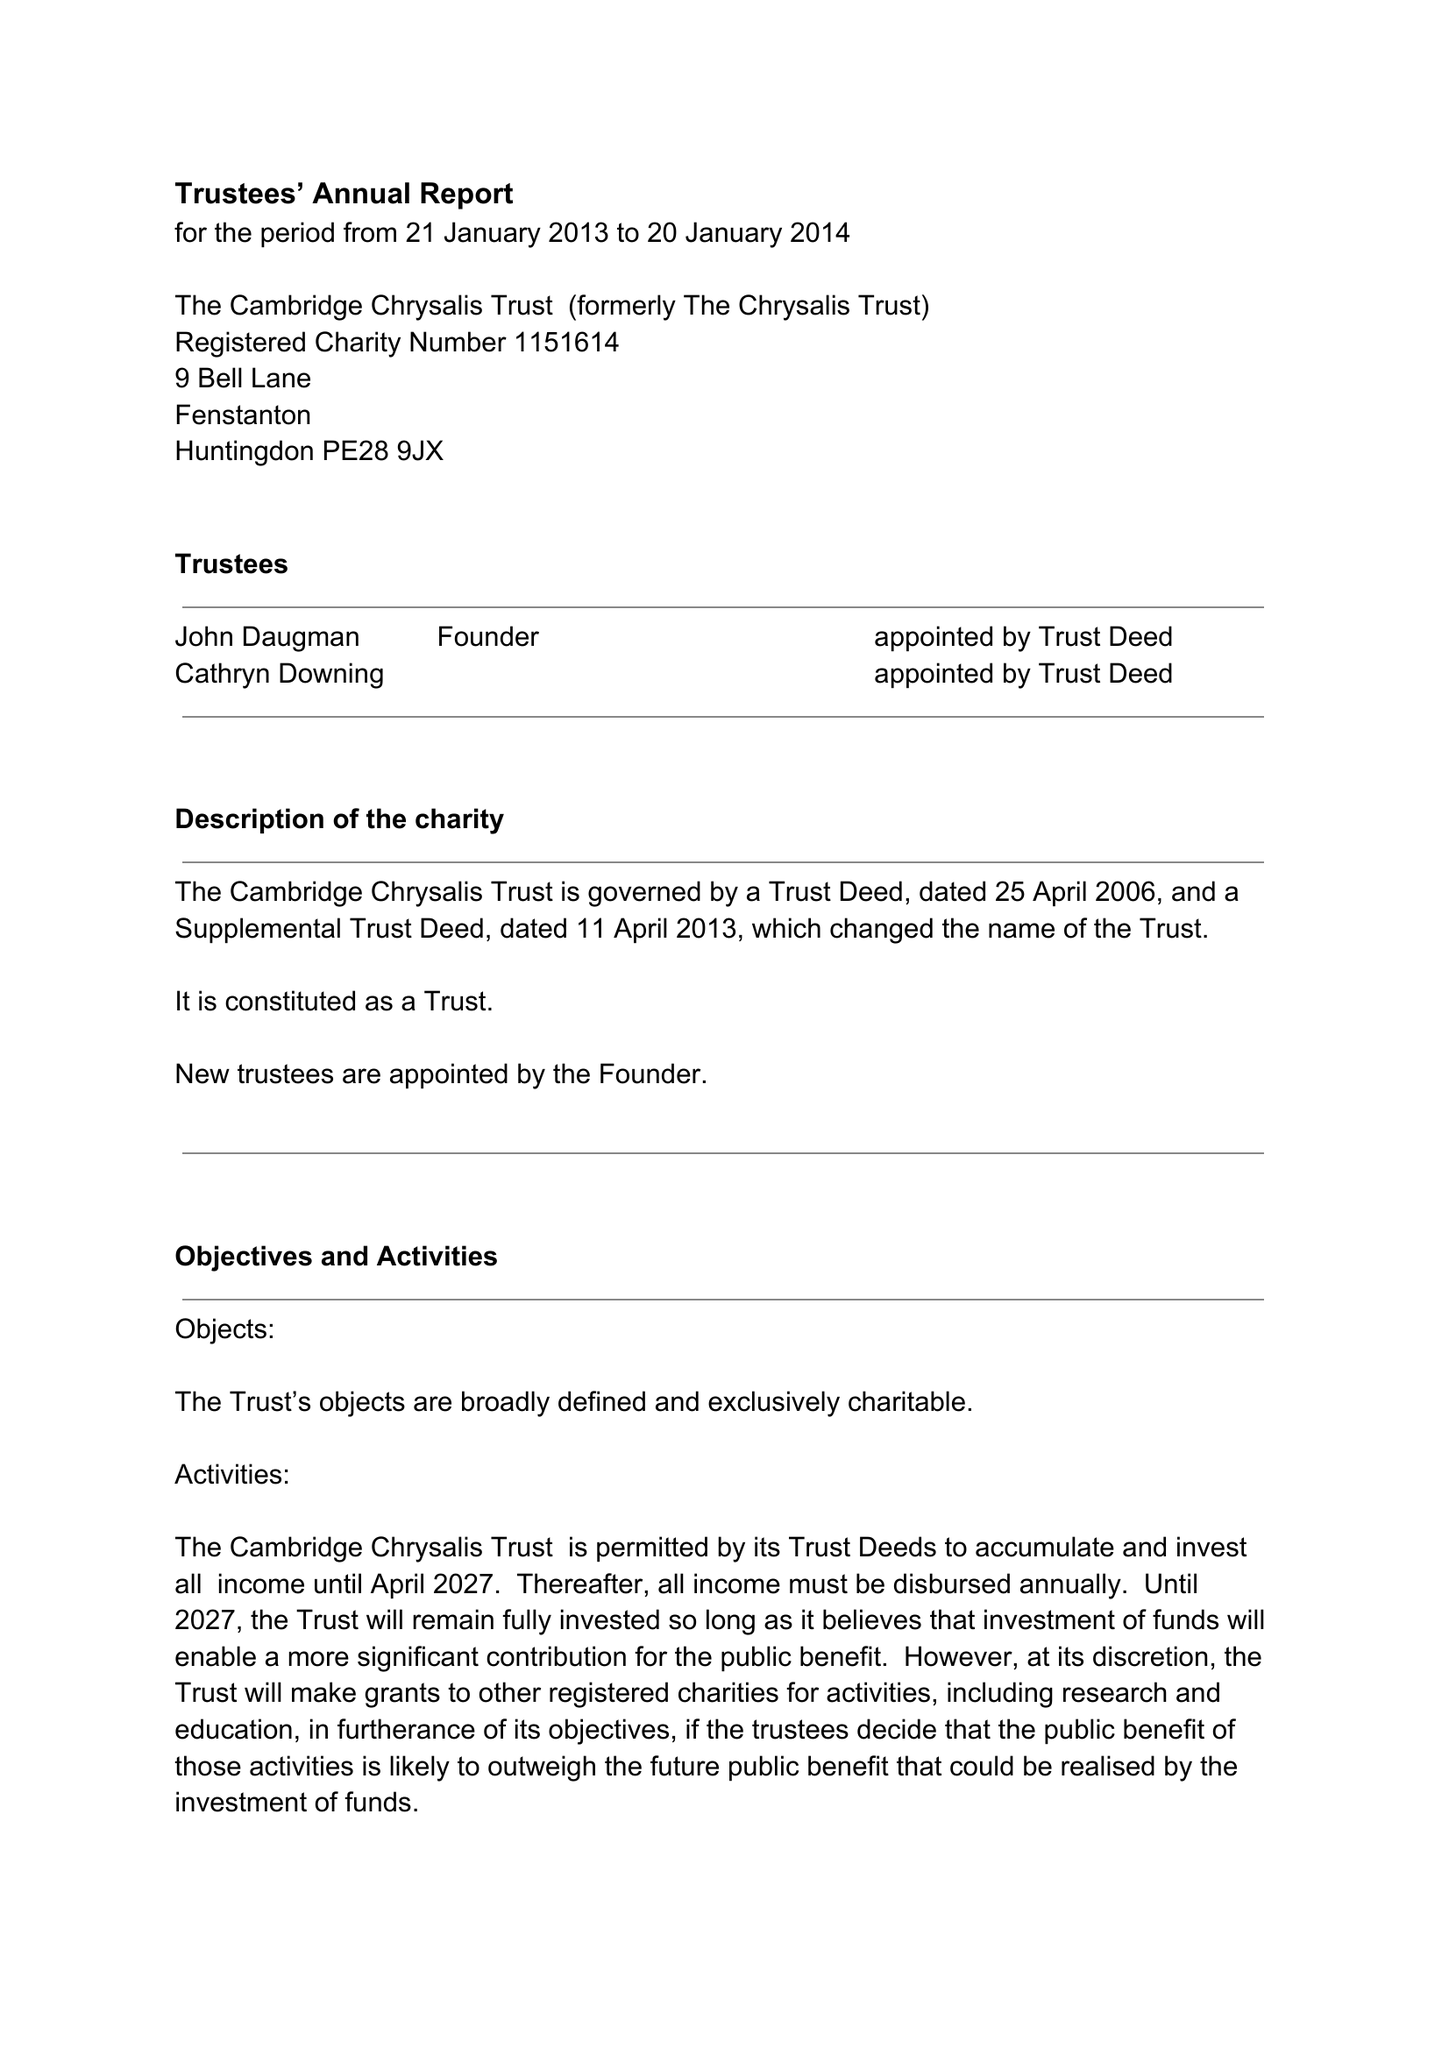What is the value for the charity_number?
Answer the question using a single word or phrase. 1151614 